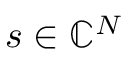<formula> <loc_0><loc_0><loc_500><loc_500>s \in \mathbb { C } ^ { N }</formula> 